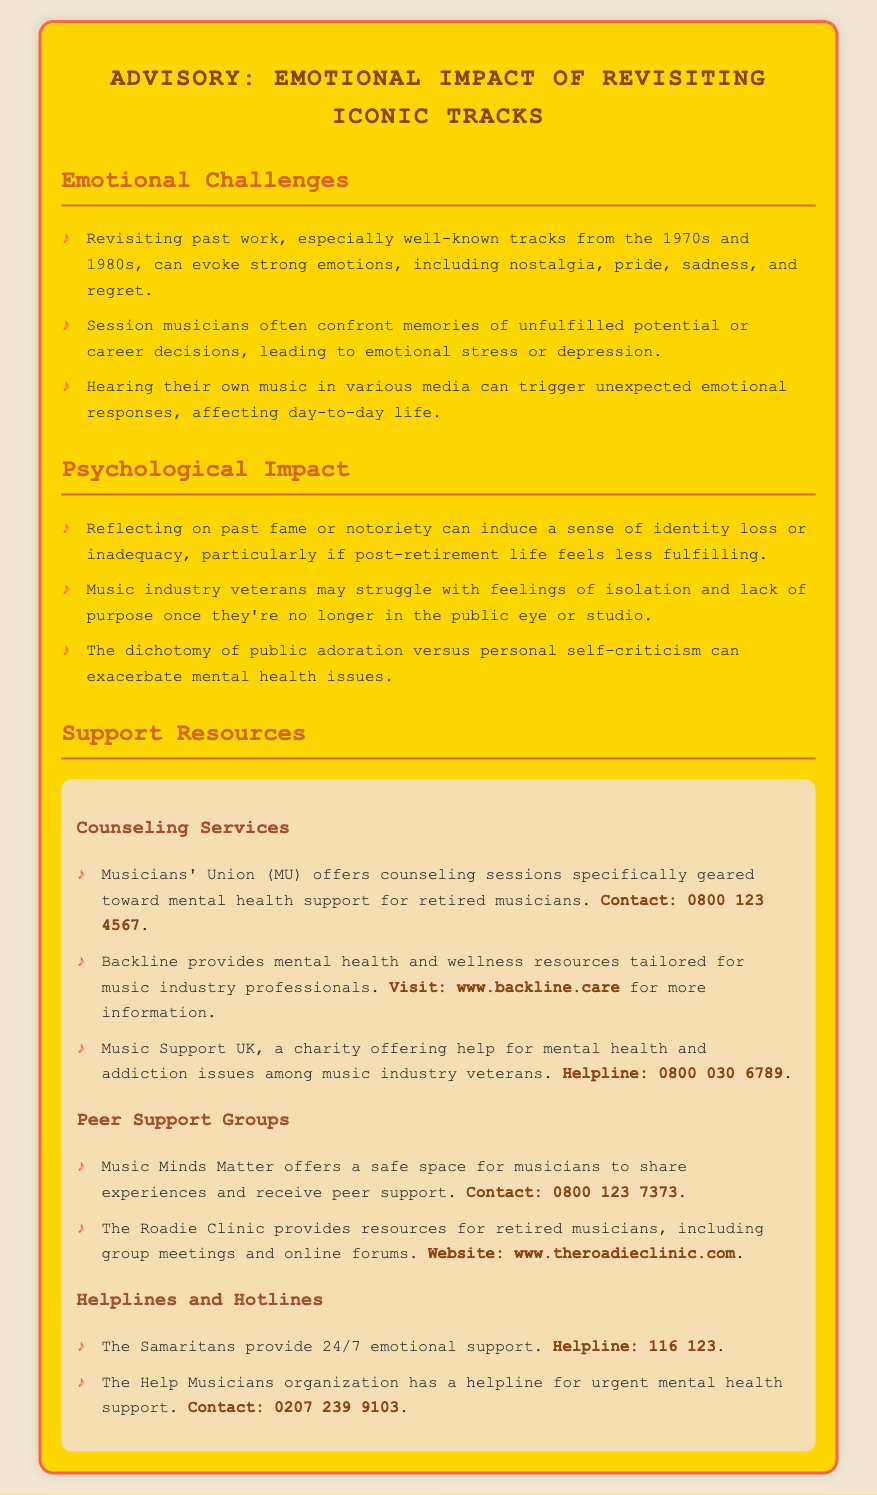What is the title of the document? The title of the document is presented in the header section of the rendered page.
Answer: Advisory: Emotional Impact of Revisiting Iconic Tracks How can one contact Musicians' Union? The contact information for Musicians' Union is included in the Support Resources section of the document.
Answer: 0800 123 4567 What emotional challenges are associated with revisiting iconic tracks? The document lists specific emotional challenges under the Emotional Challenges section that individuals may face.
Answer: Nostalgia, pride, sadness, and regret What organization offers peer support for musicians? The document mentions specific organizations that provide peer support resources.
Answer: Music Minds Matter What hotline provides 24/7 emotional support? The document lists helplines in the Helplines and Hotlines section specifically for urgent emotional support.
Answer: 116 123 